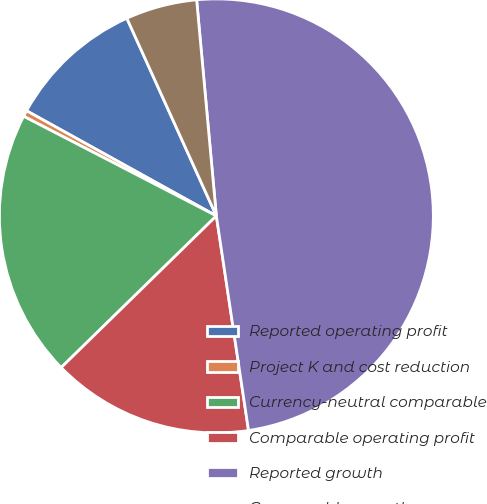Convert chart. <chart><loc_0><loc_0><loc_500><loc_500><pie_chart><fcel>Reported operating profit<fcel>Project K and cost reduction<fcel>Currency-neutral comparable<fcel>Comparable operating profit<fcel>Reported growth<fcel>Comparable growth<nl><fcel>10.18%<fcel>0.46%<fcel>19.91%<fcel>15.05%<fcel>49.08%<fcel>5.32%<nl></chart> 